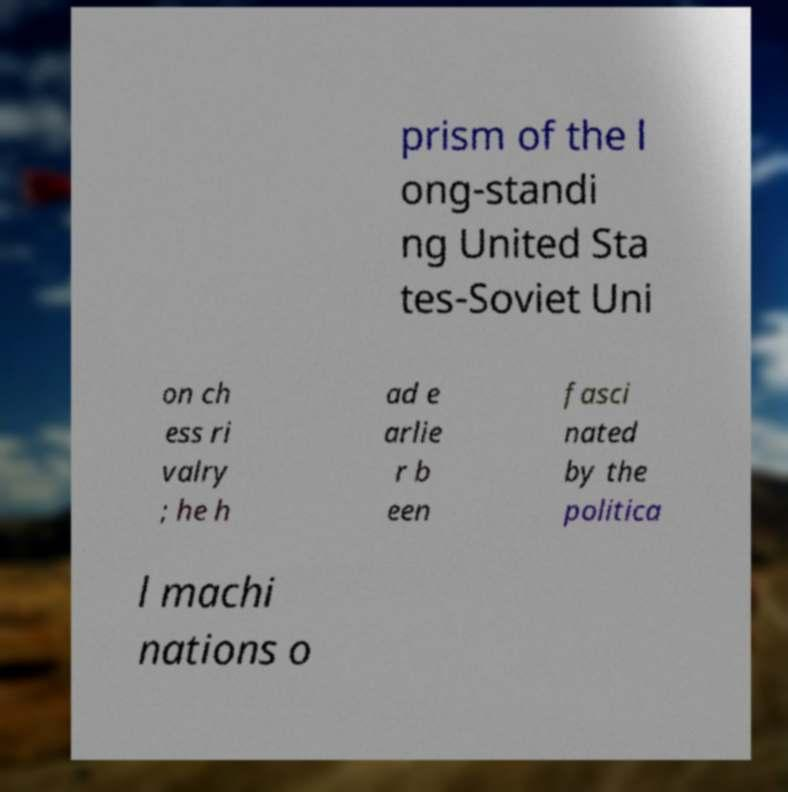Could you assist in decoding the text presented in this image and type it out clearly? prism of the l ong-standi ng United Sta tes-Soviet Uni on ch ess ri valry ; he h ad e arlie r b een fasci nated by the politica l machi nations o 